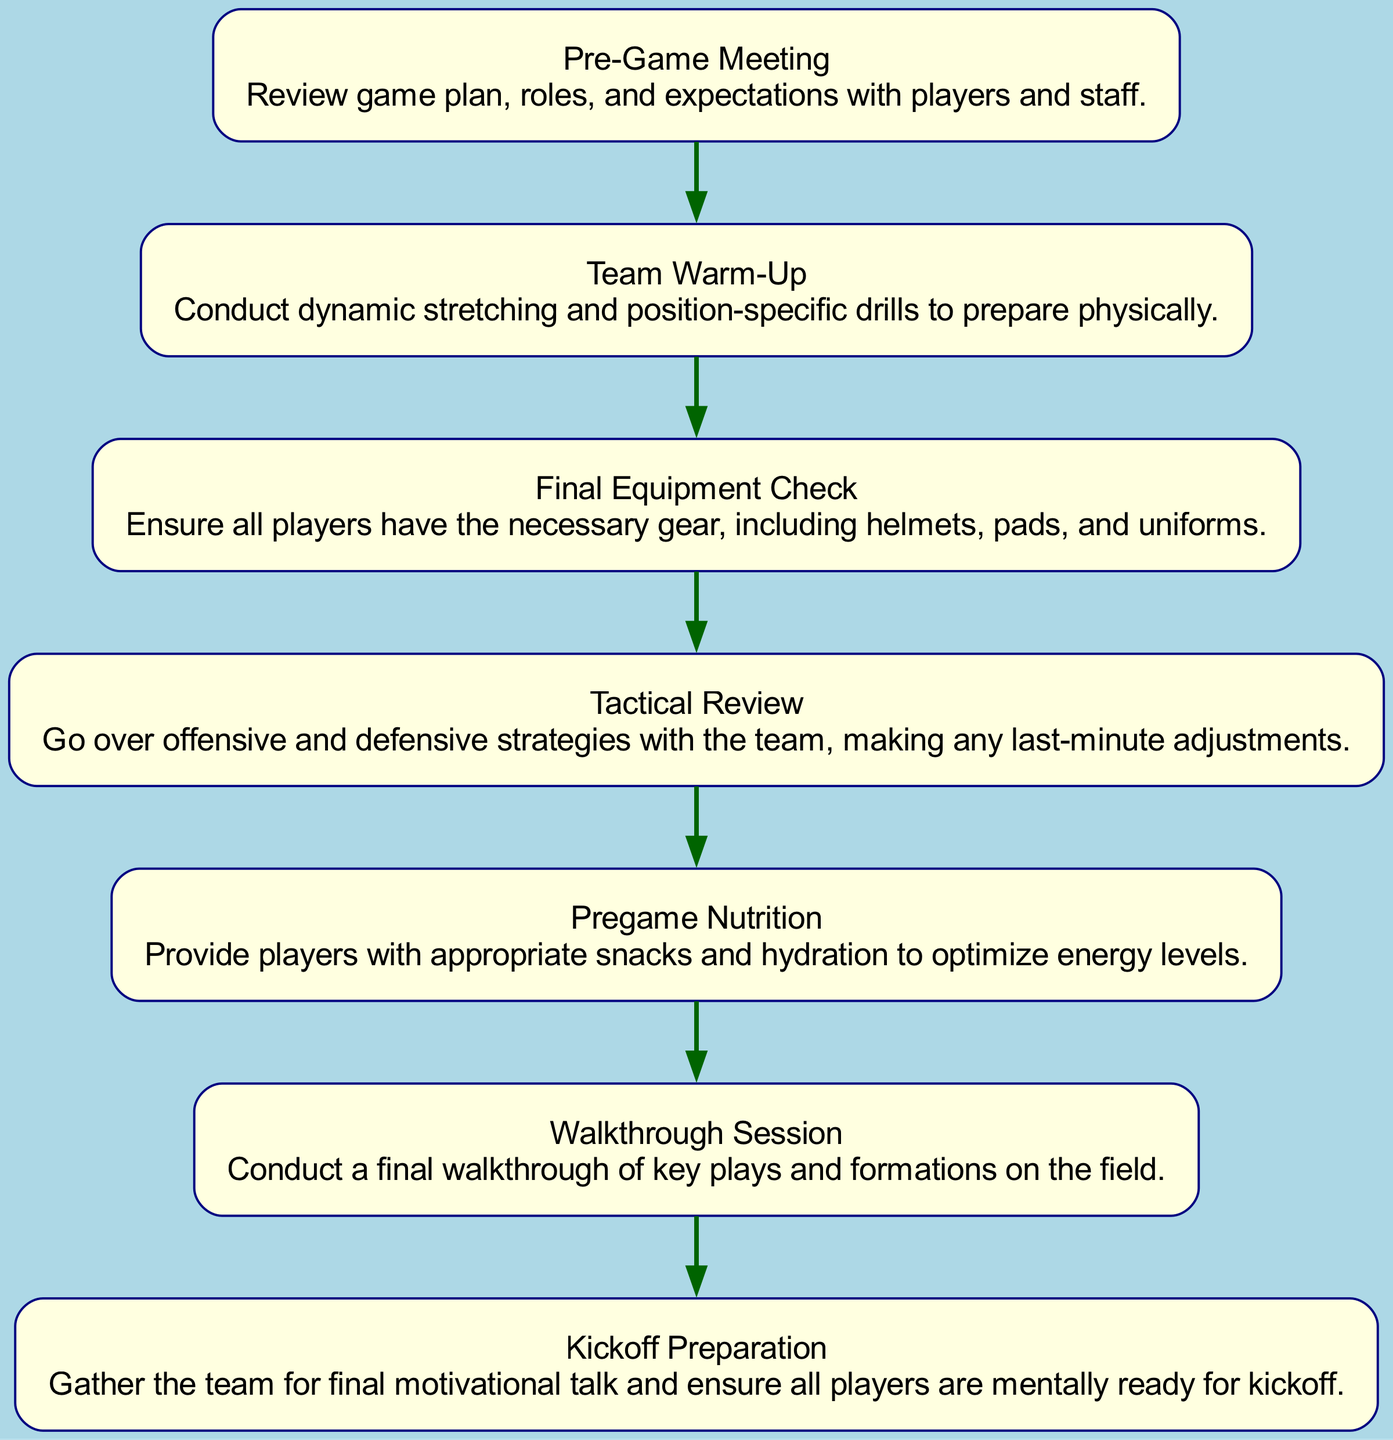What is the first step in the game day preparation timeline? The diagram shows that the first step is the "Pre-Game Meeting". This is indicated by the starting node, which is the first box in the flow chart.
Answer: Pre-Game Meeting How many total nodes are present in the diagram? To determine the total nodes, we count each individual step represented in the flow chart. There are seven steps listed.
Answer: 7 What is the last node before Kickoff Preparation? The diagram shows that the last step before "Kickoff Preparation" is the "Walkthrough Session". This can be identified by following the flow from the preceding node.
Answer: Walkthrough Session Which step involves reviewing offensive and defensive strategies? The step that specifically mentions "reviewing" offensive and defensive strategies is "Tactical Review". This is mentioned clearly in the details of that node.
Answer: Tactical Review What type of activities are included in the Team Warm-Up step? The "Team Warm-Up" step includes activities such as conducting dynamic stretching and position-specific drills. It specifically indicates preparation for physical activity.
Answer: Dynamic stretching and position-specific drills Which two steps directly precede the Pregame Nutrition? The flow chart shows that the two steps right before "Pregame Nutrition" are "Final Equipment Check" and "Tactical Review". This can be confirmed by tracing the arrow connections in the diagram.
Answer: Final Equipment Check and Tactical Review What is the purpose of the Kickoff Preparation step? The purpose of the "Kickoff Preparation" step is to gather the team for a final motivational talk and ensure mental readiness. This is stated clearly in the details for that node, explaining its significance.
Answer: Final motivational talk and mental readiness How does the Team Warm-Up relate to the Player’s physical preparation? The "Team Warm-Up" is intended to prepare players physically, which is essential before the game. This indicates its direct relationship with the players' readiness for competition.
Answer: Prepare players physically 